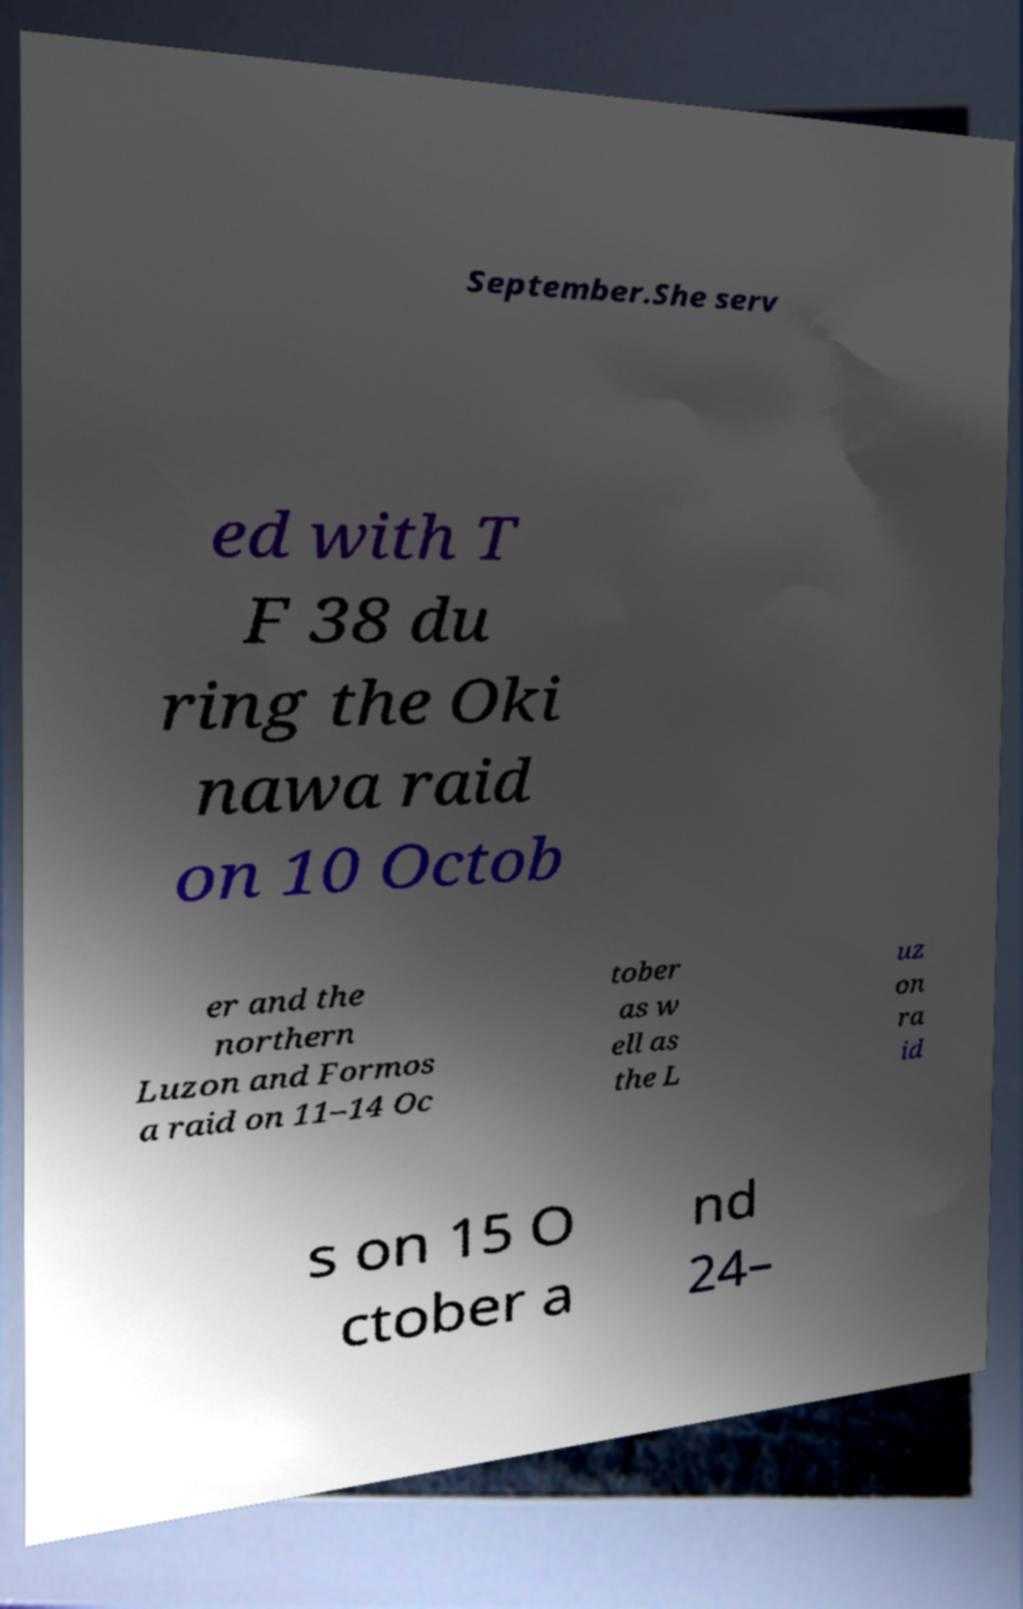Could you extract and type out the text from this image? September.She serv ed with T F 38 du ring the Oki nawa raid on 10 Octob er and the northern Luzon and Formos a raid on 11–14 Oc tober as w ell as the L uz on ra id s on 15 O ctober a nd 24– 